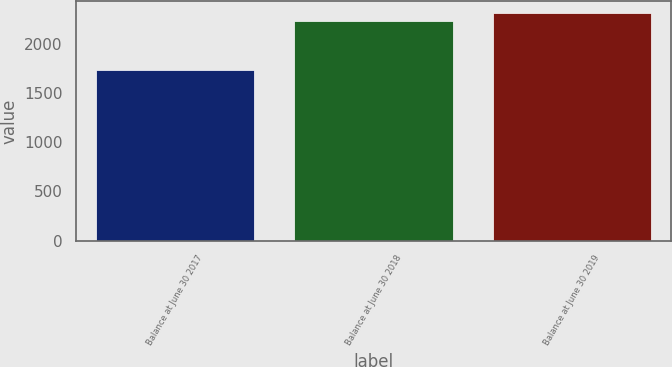Convert chart. <chart><loc_0><loc_0><loc_500><loc_500><bar_chart><fcel>Balance at June 30 2017<fcel>Balance at June 30 2018<fcel>Balance at June 30 2019<nl><fcel>1736.2<fcel>2238.7<fcel>2318.2<nl></chart> 